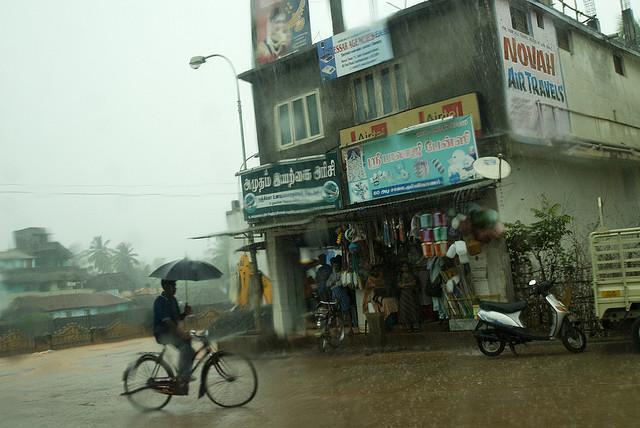Which person gets the most soaked?
From the following four choices, select the correct answer to address the question.
Options: Woman, cyclist, short man, tall man. Cyclist. 